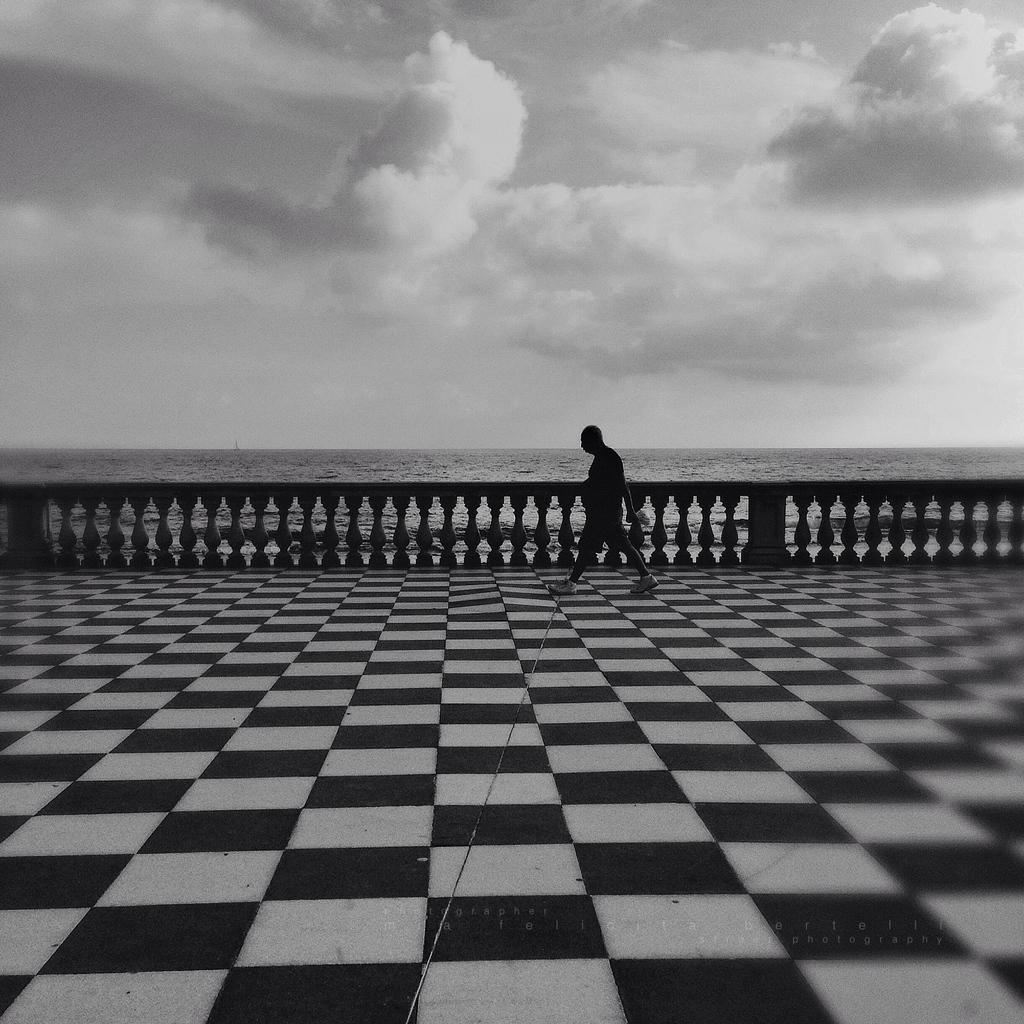Where was the picture taken? The picture was taken outside. What is the person in the image doing? The person is walking in the image. On what surface is the person walking? The person is walking on the ground. What can be seen in the background of the image? The sky is visible in the background of the image. How would you describe the sky in the image? The sky is full of clouds. What type of door can be seen in the image? There is no door present in the image; it was taken outside. Can you hear the person laughing in the image? The image is a still photograph, so there is no sound or laughter present. 